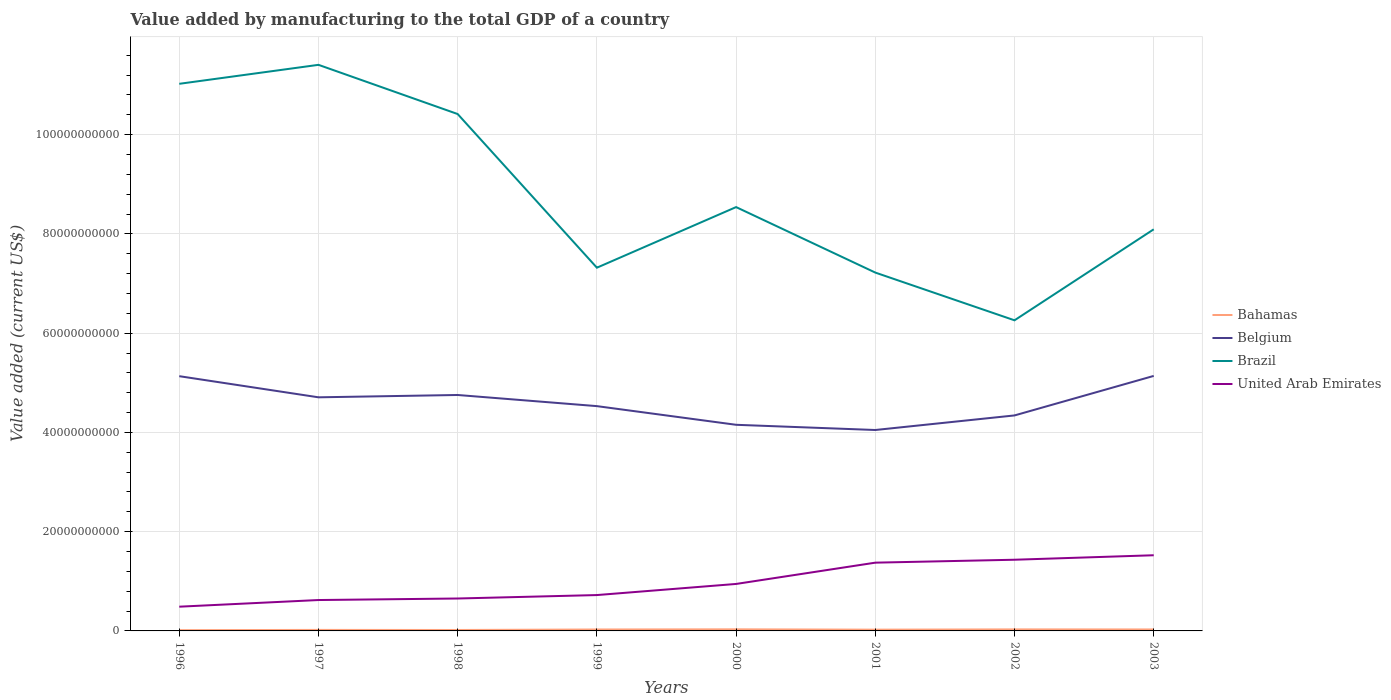Does the line corresponding to Belgium intersect with the line corresponding to United Arab Emirates?
Ensure brevity in your answer.  No. Across all years, what is the maximum value added by manufacturing to the total GDP in Brazil?
Provide a short and direct response. 6.26e+1. What is the total value added by manufacturing to the total GDP in Bahamas in the graph?
Offer a very short reply. 2.64e+07. What is the difference between the highest and the second highest value added by manufacturing to the total GDP in Belgium?
Provide a succinct answer. 1.09e+1. What is the difference between the highest and the lowest value added by manufacturing to the total GDP in United Arab Emirates?
Make the answer very short. 3. How many lines are there?
Provide a short and direct response. 4. Does the graph contain grids?
Keep it short and to the point. Yes. How are the legend labels stacked?
Offer a very short reply. Vertical. What is the title of the graph?
Your answer should be compact. Value added by manufacturing to the total GDP of a country. What is the label or title of the Y-axis?
Keep it short and to the point. Value added (current US$). What is the Value added (current US$) of Bahamas in 1996?
Your answer should be very brief. 1.54e+08. What is the Value added (current US$) in Belgium in 1996?
Ensure brevity in your answer.  5.13e+1. What is the Value added (current US$) of Brazil in 1996?
Give a very brief answer. 1.10e+11. What is the Value added (current US$) in United Arab Emirates in 1996?
Make the answer very short. 4.88e+09. What is the Value added (current US$) in Bahamas in 1997?
Provide a succinct answer. 2.05e+08. What is the Value added (current US$) of Belgium in 1997?
Make the answer very short. 4.71e+1. What is the Value added (current US$) in Brazil in 1997?
Your answer should be very brief. 1.14e+11. What is the Value added (current US$) of United Arab Emirates in 1997?
Keep it short and to the point. 6.22e+09. What is the Value added (current US$) of Bahamas in 1998?
Offer a very short reply. 1.88e+08. What is the Value added (current US$) of Belgium in 1998?
Your response must be concise. 4.75e+1. What is the Value added (current US$) of Brazil in 1998?
Keep it short and to the point. 1.04e+11. What is the Value added (current US$) in United Arab Emirates in 1998?
Keep it short and to the point. 6.53e+09. What is the Value added (current US$) of Bahamas in 1999?
Make the answer very short. 2.90e+08. What is the Value added (current US$) of Belgium in 1999?
Make the answer very short. 4.53e+1. What is the Value added (current US$) in Brazil in 1999?
Offer a very short reply. 7.32e+1. What is the Value added (current US$) in United Arab Emirates in 1999?
Provide a short and direct response. 7.23e+09. What is the Value added (current US$) in Bahamas in 2000?
Keep it short and to the point. 3.22e+08. What is the Value added (current US$) of Belgium in 2000?
Ensure brevity in your answer.  4.15e+1. What is the Value added (current US$) of Brazil in 2000?
Your answer should be very brief. 8.54e+1. What is the Value added (current US$) of United Arab Emirates in 2000?
Keep it short and to the point. 9.47e+09. What is the Value added (current US$) of Bahamas in 2001?
Provide a short and direct response. 2.54e+08. What is the Value added (current US$) in Belgium in 2001?
Ensure brevity in your answer.  4.05e+1. What is the Value added (current US$) of Brazil in 2001?
Ensure brevity in your answer.  7.22e+1. What is the Value added (current US$) in United Arab Emirates in 2001?
Provide a succinct answer. 1.38e+1. What is the Value added (current US$) of Bahamas in 2002?
Offer a terse response. 3.09e+08. What is the Value added (current US$) of Belgium in 2002?
Keep it short and to the point. 4.34e+1. What is the Value added (current US$) of Brazil in 2002?
Your answer should be very brief. 6.26e+1. What is the Value added (current US$) in United Arab Emirates in 2002?
Offer a terse response. 1.43e+1. What is the Value added (current US$) in Bahamas in 2003?
Provide a short and direct response. 2.95e+08. What is the Value added (current US$) in Belgium in 2003?
Your answer should be compact. 5.14e+1. What is the Value added (current US$) of Brazil in 2003?
Make the answer very short. 8.09e+1. What is the Value added (current US$) of United Arab Emirates in 2003?
Offer a very short reply. 1.52e+1. Across all years, what is the maximum Value added (current US$) of Bahamas?
Offer a very short reply. 3.22e+08. Across all years, what is the maximum Value added (current US$) in Belgium?
Keep it short and to the point. 5.14e+1. Across all years, what is the maximum Value added (current US$) in Brazil?
Offer a terse response. 1.14e+11. Across all years, what is the maximum Value added (current US$) of United Arab Emirates?
Your response must be concise. 1.52e+1. Across all years, what is the minimum Value added (current US$) of Bahamas?
Ensure brevity in your answer.  1.54e+08. Across all years, what is the minimum Value added (current US$) of Belgium?
Ensure brevity in your answer.  4.05e+1. Across all years, what is the minimum Value added (current US$) of Brazil?
Offer a terse response. 6.26e+1. Across all years, what is the minimum Value added (current US$) in United Arab Emirates?
Your response must be concise. 4.88e+09. What is the total Value added (current US$) of Bahamas in the graph?
Give a very brief answer. 2.02e+09. What is the total Value added (current US$) in Belgium in the graph?
Offer a terse response. 3.68e+11. What is the total Value added (current US$) of Brazil in the graph?
Provide a short and direct response. 7.03e+11. What is the total Value added (current US$) in United Arab Emirates in the graph?
Offer a very short reply. 7.77e+1. What is the difference between the Value added (current US$) of Bahamas in 1996 and that in 1997?
Your answer should be compact. -5.09e+07. What is the difference between the Value added (current US$) of Belgium in 1996 and that in 1997?
Give a very brief answer. 4.26e+09. What is the difference between the Value added (current US$) in Brazil in 1996 and that in 1997?
Provide a succinct answer. -3.82e+09. What is the difference between the Value added (current US$) in United Arab Emirates in 1996 and that in 1997?
Your response must be concise. -1.34e+09. What is the difference between the Value added (current US$) of Bahamas in 1996 and that in 1998?
Keep it short and to the point. -3.41e+07. What is the difference between the Value added (current US$) of Belgium in 1996 and that in 1998?
Give a very brief answer. 3.79e+09. What is the difference between the Value added (current US$) in Brazil in 1996 and that in 1998?
Offer a very short reply. 6.09e+09. What is the difference between the Value added (current US$) in United Arab Emirates in 1996 and that in 1998?
Give a very brief answer. -1.65e+09. What is the difference between the Value added (current US$) in Bahamas in 1996 and that in 1999?
Provide a succinct answer. -1.36e+08. What is the difference between the Value added (current US$) in Belgium in 1996 and that in 1999?
Provide a succinct answer. 6.03e+09. What is the difference between the Value added (current US$) of Brazil in 1996 and that in 1999?
Make the answer very short. 3.71e+1. What is the difference between the Value added (current US$) in United Arab Emirates in 1996 and that in 1999?
Provide a short and direct response. -2.34e+09. What is the difference between the Value added (current US$) in Bahamas in 1996 and that in 2000?
Make the answer very short. -1.68e+08. What is the difference between the Value added (current US$) in Belgium in 1996 and that in 2000?
Provide a short and direct response. 9.80e+09. What is the difference between the Value added (current US$) of Brazil in 1996 and that in 2000?
Your answer should be compact. 2.48e+1. What is the difference between the Value added (current US$) in United Arab Emirates in 1996 and that in 2000?
Your response must be concise. -4.58e+09. What is the difference between the Value added (current US$) in Bahamas in 1996 and that in 2001?
Your answer should be compact. -9.97e+07. What is the difference between the Value added (current US$) in Belgium in 1996 and that in 2001?
Offer a terse response. 1.08e+1. What is the difference between the Value added (current US$) in Brazil in 1996 and that in 2001?
Provide a short and direct response. 3.80e+1. What is the difference between the Value added (current US$) in United Arab Emirates in 1996 and that in 2001?
Your response must be concise. -8.87e+09. What is the difference between the Value added (current US$) in Bahamas in 1996 and that in 2002?
Ensure brevity in your answer.  -1.55e+08. What is the difference between the Value added (current US$) in Belgium in 1996 and that in 2002?
Give a very brief answer. 7.91e+09. What is the difference between the Value added (current US$) in Brazil in 1996 and that in 2002?
Offer a terse response. 4.77e+1. What is the difference between the Value added (current US$) in United Arab Emirates in 1996 and that in 2002?
Make the answer very short. -9.46e+09. What is the difference between the Value added (current US$) in Bahamas in 1996 and that in 2003?
Make the answer very short. -1.41e+08. What is the difference between the Value added (current US$) of Belgium in 1996 and that in 2003?
Your answer should be compact. -5.35e+07. What is the difference between the Value added (current US$) in Brazil in 1996 and that in 2003?
Ensure brevity in your answer.  2.93e+1. What is the difference between the Value added (current US$) in United Arab Emirates in 1996 and that in 2003?
Your answer should be very brief. -1.04e+1. What is the difference between the Value added (current US$) of Bahamas in 1997 and that in 1998?
Give a very brief answer. 1.68e+07. What is the difference between the Value added (current US$) in Belgium in 1997 and that in 1998?
Provide a succinct answer. -4.68e+08. What is the difference between the Value added (current US$) of Brazil in 1997 and that in 1998?
Your answer should be compact. 9.91e+09. What is the difference between the Value added (current US$) of United Arab Emirates in 1997 and that in 1998?
Keep it short and to the point. -3.07e+08. What is the difference between the Value added (current US$) in Bahamas in 1997 and that in 1999?
Offer a very short reply. -8.48e+07. What is the difference between the Value added (current US$) of Belgium in 1997 and that in 1999?
Give a very brief answer. 1.78e+09. What is the difference between the Value added (current US$) in Brazil in 1997 and that in 1999?
Your answer should be very brief. 4.09e+1. What is the difference between the Value added (current US$) in United Arab Emirates in 1997 and that in 1999?
Offer a very short reply. -1.00e+09. What is the difference between the Value added (current US$) in Bahamas in 1997 and that in 2000?
Offer a very short reply. -1.17e+08. What is the difference between the Value added (current US$) of Belgium in 1997 and that in 2000?
Your response must be concise. 5.54e+09. What is the difference between the Value added (current US$) in Brazil in 1997 and that in 2000?
Your answer should be very brief. 2.87e+1. What is the difference between the Value added (current US$) in United Arab Emirates in 1997 and that in 2000?
Offer a very short reply. -3.24e+09. What is the difference between the Value added (current US$) in Bahamas in 1997 and that in 2001?
Make the answer very short. -4.89e+07. What is the difference between the Value added (current US$) of Belgium in 1997 and that in 2001?
Give a very brief answer. 6.59e+09. What is the difference between the Value added (current US$) of Brazil in 1997 and that in 2001?
Offer a very short reply. 4.19e+1. What is the difference between the Value added (current US$) of United Arab Emirates in 1997 and that in 2001?
Your response must be concise. -7.53e+09. What is the difference between the Value added (current US$) in Bahamas in 1997 and that in 2002?
Provide a short and direct response. -1.04e+08. What is the difference between the Value added (current US$) of Belgium in 1997 and that in 2002?
Provide a short and direct response. 3.65e+09. What is the difference between the Value added (current US$) in Brazil in 1997 and that in 2002?
Keep it short and to the point. 5.15e+1. What is the difference between the Value added (current US$) of United Arab Emirates in 1997 and that in 2002?
Provide a succinct answer. -8.12e+09. What is the difference between the Value added (current US$) in Bahamas in 1997 and that in 2003?
Your response must be concise. -9.03e+07. What is the difference between the Value added (current US$) in Belgium in 1997 and that in 2003?
Your answer should be compact. -4.31e+09. What is the difference between the Value added (current US$) in Brazil in 1997 and that in 2003?
Ensure brevity in your answer.  3.31e+1. What is the difference between the Value added (current US$) of United Arab Emirates in 1997 and that in 2003?
Your answer should be very brief. -9.02e+09. What is the difference between the Value added (current US$) of Bahamas in 1998 and that in 1999?
Your answer should be compact. -1.02e+08. What is the difference between the Value added (current US$) of Belgium in 1998 and that in 1999?
Offer a terse response. 2.24e+09. What is the difference between the Value added (current US$) of Brazil in 1998 and that in 1999?
Offer a very short reply. 3.10e+1. What is the difference between the Value added (current US$) in United Arab Emirates in 1998 and that in 1999?
Provide a short and direct response. -6.95e+08. What is the difference between the Value added (current US$) in Bahamas in 1998 and that in 2000?
Make the answer very short. -1.34e+08. What is the difference between the Value added (current US$) of Belgium in 1998 and that in 2000?
Provide a succinct answer. 6.01e+09. What is the difference between the Value added (current US$) in Brazil in 1998 and that in 2000?
Offer a terse response. 1.87e+1. What is the difference between the Value added (current US$) of United Arab Emirates in 1998 and that in 2000?
Your answer should be compact. -2.93e+09. What is the difference between the Value added (current US$) in Bahamas in 1998 and that in 2001?
Give a very brief answer. -6.57e+07. What is the difference between the Value added (current US$) in Belgium in 1998 and that in 2001?
Your response must be concise. 7.05e+09. What is the difference between the Value added (current US$) of Brazil in 1998 and that in 2001?
Your response must be concise. 3.19e+1. What is the difference between the Value added (current US$) in United Arab Emirates in 1998 and that in 2001?
Make the answer very short. -7.22e+09. What is the difference between the Value added (current US$) in Bahamas in 1998 and that in 2002?
Your answer should be very brief. -1.21e+08. What is the difference between the Value added (current US$) in Belgium in 1998 and that in 2002?
Offer a terse response. 4.12e+09. What is the difference between the Value added (current US$) of Brazil in 1998 and that in 2002?
Your answer should be compact. 4.16e+1. What is the difference between the Value added (current US$) of United Arab Emirates in 1998 and that in 2002?
Provide a short and direct response. -7.81e+09. What is the difference between the Value added (current US$) in Bahamas in 1998 and that in 2003?
Offer a very short reply. -1.07e+08. What is the difference between the Value added (current US$) in Belgium in 1998 and that in 2003?
Your answer should be compact. -3.84e+09. What is the difference between the Value added (current US$) in Brazil in 1998 and that in 2003?
Offer a terse response. 2.32e+1. What is the difference between the Value added (current US$) in United Arab Emirates in 1998 and that in 2003?
Provide a succinct answer. -8.72e+09. What is the difference between the Value added (current US$) in Bahamas in 1999 and that in 2000?
Keep it short and to the point. -3.19e+07. What is the difference between the Value added (current US$) in Belgium in 1999 and that in 2000?
Your response must be concise. 3.76e+09. What is the difference between the Value added (current US$) in Brazil in 1999 and that in 2000?
Your answer should be compact. -1.22e+1. What is the difference between the Value added (current US$) in United Arab Emirates in 1999 and that in 2000?
Ensure brevity in your answer.  -2.24e+09. What is the difference between the Value added (current US$) in Bahamas in 1999 and that in 2001?
Ensure brevity in your answer.  3.59e+07. What is the difference between the Value added (current US$) in Belgium in 1999 and that in 2001?
Make the answer very short. 4.81e+09. What is the difference between the Value added (current US$) in Brazil in 1999 and that in 2001?
Keep it short and to the point. 9.84e+08. What is the difference between the Value added (current US$) in United Arab Emirates in 1999 and that in 2001?
Make the answer very short. -6.53e+09. What is the difference between the Value added (current US$) of Bahamas in 1999 and that in 2002?
Ensure brevity in your answer.  -1.96e+07. What is the difference between the Value added (current US$) of Belgium in 1999 and that in 2002?
Your answer should be very brief. 1.87e+09. What is the difference between the Value added (current US$) of Brazil in 1999 and that in 2002?
Give a very brief answer. 1.06e+1. What is the difference between the Value added (current US$) of United Arab Emirates in 1999 and that in 2002?
Provide a succinct answer. -7.12e+09. What is the difference between the Value added (current US$) of Bahamas in 1999 and that in 2003?
Offer a terse response. -5.49e+06. What is the difference between the Value added (current US$) in Belgium in 1999 and that in 2003?
Provide a succinct answer. -6.09e+09. What is the difference between the Value added (current US$) of Brazil in 1999 and that in 2003?
Provide a succinct answer. -7.74e+09. What is the difference between the Value added (current US$) in United Arab Emirates in 1999 and that in 2003?
Give a very brief answer. -8.02e+09. What is the difference between the Value added (current US$) of Bahamas in 2000 and that in 2001?
Your answer should be very brief. 6.78e+07. What is the difference between the Value added (current US$) of Belgium in 2000 and that in 2001?
Your response must be concise. 1.05e+09. What is the difference between the Value added (current US$) in Brazil in 2000 and that in 2001?
Your answer should be very brief. 1.32e+1. What is the difference between the Value added (current US$) of United Arab Emirates in 2000 and that in 2001?
Your answer should be very brief. -4.29e+09. What is the difference between the Value added (current US$) in Bahamas in 2000 and that in 2002?
Your answer should be very brief. 1.23e+07. What is the difference between the Value added (current US$) in Belgium in 2000 and that in 2002?
Provide a short and direct response. -1.89e+09. What is the difference between the Value added (current US$) of Brazil in 2000 and that in 2002?
Keep it short and to the point. 2.28e+1. What is the difference between the Value added (current US$) in United Arab Emirates in 2000 and that in 2002?
Your response must be concise. -4.88e+09. What is the difference between the Value added (current US$) in Bahamas in 2000 and that in 2003?
Give a very brief answer. 2.64e+07. What is the difference between the Value added (current US$) of Belgium in 2000 and that in 2003?
Provide a succinct answer. -9.85e+09. What is the difference between the Value added (current US$) of Brazil in 2000 and that in 2003?
Ensure brevity in your answer.  4.48e+09. What is the difference between the Value added (current US$) of United Arab Emirates in 2000 and that in 2003?
Your answer should be very brief. -5.78e+09. What is the difference between the Value added (current US$) in Bahamas in 2001 and that in 2002?
Keep it short and to the point. -5.56e+07. What is the difference between the Value added (current US$) of Belgium in 2001 and that in 2002?
Your answer should be very brief. -2.94e+09. What is the difference between the Value added (current US$) in Brazil in 2001 and that in 2002?
Offer a terse response. 9.62e+09. What is the difference between the Value added (current US$) in United Arab Emirates in 2001 and that in 2002?
Keep it short and to the point. -5.91e+08. What is the difference between the Value added (current US$) of Bahamas in 2001 and that in 2003?
Your answer should be compact. -4.14e+07. What is the difference between the Value added (current US$) of Belgium in 2001 and that in 2003?
Your answer should be compact. -1.09e+1. What is the difference between the Value added (current US$) in Brazil in 2001 and that in 2003?
Your answer should be compact. -8.72e+09. What is the difference between the Value added (current US$) of United Arab Emirates in 2001 and that in 2003?
Provide a short and direct response. -1.49e+09. What is the difference between the Value added (current US$) in Bahamas in 2002 and that in 2003?
Your response must be concise. 1.41e+07. What is the difference between the Value added (current US$) of Belgium in 2002 and that in 2003?
Provide a succinct answer. -7.96e+09. What is the difference between the Value added (current US$) of Brazil in 2002 and that in 2003?
Your response must be concise. -1.83e+1. What is the difference between the Value added (current US$) of United Arab Emirates in 2002 and that in 2003?
Make the answer very short. -9.02e+08. What is the difference between the Value added (current US$) of Bahamas in 1996 and the Value added (current US$) of Belgium in 1997?
Provide a short and direct response. -4.69e+1. What is the difference between the Value added (current US$) of Bahamas in 1996 and the Value added (current US$) of Brazil in 1997?
Provide a succinct answer. -1.14e+11. What is the difference between the Value added (current US$) in Bahamas in 1996 and the Value added (current US$) in United Arab Emirates in 1997?
Give a very brief answer. -6.07e+09. What is the difference between the Value added (current US$) in Belgium in 1996 and the Value added (current US$) in Brazil in 1997?
Offer a very short reply. -6.27e+1. What is the difference between the Value added (current US$) of Belgium in 1996 and the Value added (current US$) of United Arab Emirates in 1997?
Make the answer very short. 4.51e+1. What is the difference between the Value added (current US$) in Brazil in 1996 and the Value added (current US$) in United Arab Emirates in 1997?
Provide a succinct answer. 1.04e+11. What is the difference between the Value added (current US$) of Bahamas in 1996 and the Value added (current US$) of Belgium in 1998?
Your answer should be very brief. -4.74e+1. What is the difference between the Value added (current US$) of Bahamas in 1996 and the Value added (current US$) of Brazil in 1998?
Offer a terse response. -1.04e+11. What is the difference between the Value added (current US$) in Bahamas in 1996 and the Value added (current US$) in United Arab Emirates in 1998?
Provide a short and direct response. -6.38e+09. What is the difference between the Value added (current US$) in Belgium in 1996 and the Value added (current US$) in Brazil in 1998?
Your answer should be compact. -5.28e+1. What is the difference between the Value added (current US$) in Belgium in 1996 and the Value added (current US$) in United Arab Emirates in 1998?
Make the answer very short. 4.48e+1. What is the difference between the Value added (current US$) of Brazil in 1996 and the Value added (current US$) of United Arab Emirates in 1998?
Your response must be concise. 1.04e+11. What is the difference between the Value added (current US$) in Bahamas in 1996 and the Value added (current US$) in Belgium in 1999?
Make the answer very short. -4.51e+1. What is the difference between the Value added (current US$) of Bahamas in 1996 and the Value added (current US$) of Brazil in 1999?
Ensure brevity in your answer.  -7.30e+1. What is the difference between the Value added (current US$) of Bahamas in 1996 and the Value added (current US$) of United Arab Emirates in 1999?
Make the answer very short. -7.07e+09. What is the difference between the Value added (current US$) in Belgium in 1996 and the Value added (current US$) in Brazil in 1999?
Provide a short and direct response. -2.19e+1. What is the difference between the Value added (current US$) of Belgium in 1996 and the Value added (current US$) of United Arab Emirates in 1999?
Offer a very short reply. 4.41e+1. What is the difference between the Value added (current US$) of Brazil in 1996 and the Value added (current US$) of United Arab Emirates in 1999?
Keep it short and to the point. 1.03e+11. What is the difference between the Value added (current US$) of Bahamas in 1996 and the Value added (current US$) of Belgium in 2000?
Offer a very short reply. -4.14e+1. What is the difference between the Value added (current US$) in Bahamas in 1996 and the Value added (current US$) in Brazil in 2000?
Ensure brevity in your answer.  -8.52e+1. What is the difference between the Value added (current US$) in Bahamas in 1996 and the Value added (current US$) in United Arab Emirates in 2000?
Make the answer very short. -9.31e+09. What is the difference between the Value added (current US$) of Belgium in 1996 and the Value added (current US$) of Brazil in 2000?
Make the answer very short. -3.41e+1. What is the difference between the Value added (current US$) of Belgium in 1996 and the Value added (current US$) of United Arab Emirates in 2000?
Provide a short and direct response. 4.19e+1. What is the difference between the Value added (current US$) in Brazil in 1996 and the Value added (current US$) in United Arab Emirates in 2000?
Provide a succinct answer. 1.01e+11. What is the difference between the Value added (current US$) of Bahamas in 1996 and the Value added (current US$) of Belgium in 2001?
Make the answer very short. -4.03e+1. What is the difference between the Value added (current US$) in Bahamas in 1996 and the Value added (current US$) in Brazil in 2001?
Keep it short and to the point. -7.21e+1. What is the difference between the Value added (current US$) in Bahamas in 1996 and the Value added (current US$) in United Arab Emirates in 2001?
Provide a succinct answer. -1.36e+1. What is the difference between the Value added (current US$) of Belgium in 1996 and the Value added (current US$) of Brazil in 2001?
Provide a short and direct response. -2.09e+1. What is the difference between the Value added (current US$) of Belgium in 1996 and the Value added (current US$) of United Arab Emirates in 2001?
Your answer should be compact. 3.76e+1. What is the difference between the Value added (current US$) of Brazil in 1996 and the Value added (current US$) of United Arab Emirates in 2001?
Your answer should be very brief. 9.65e+1. What is the difference between the Value added (current US$) of Bahamas in 1996 and the Value added (current US$) of Belgium in 2002?
Ensure brevity in your answer.  -4.33e+1. What is the difference between the Value added (current US$) of Bahamas in 1996 and the Value added (current US$) of Brazil in 2002?
Keep it short and to the point. -6.24e+1. What is the difference between the Value added (current US$) in Bahamas in 1996 and the Value added (current US$) in United Arab Emirates in 2002?
Give a very brief answer. -1.42e+1. What is the difference between the Value added (current US$) in Belgium in 1996 and the Value added (current US$) in Brazil in 2002?
Provide a succinct answer. -1.13e+1. What is the difference between the Value added (current US$) of Belgium in 1996 and the Value added (current US$) of United Arab Emirates in 2002?
Provide a short and direct response. 3.70e+1. What is the difference between the Value added (current US$) of Brazil in 1996 and the Value added (current US$) of United Arab Emirates in 2002?
Keep it short and to the point. 9.59e+1. What is the difference between the Value added (current US$) of Bahamas in 1996 and the Value added (current US$) of Belgium in 2003?
Provide a short and direct response. -5.12e+1. What is the difference between the Value added (current US$) in Bahamas in 1996 and the Value added (current US$) in Brazil in 2003?
Your answer should be compact. -8.08e+1. What is the difference between the Value added (current US$) of Bahamas in 1996 and the Value added (current US$) of United Arab Emirates in 2003?
Make the answer very short. -1.51e+1. What is the difference between the Value added (current US$) of Belgium in 1996 and the Value added (current US$) of Brazil in 2003?
Offer a terse response. -2.96e+1. What is the difference between the Value added (current US$) of Belgium in 1996 and the Value added (current US$) of United Arab Emirates in 2003?
Your response must be concise. 3.61e+1. What is the difference between the Value added (current US$) in Brazil in 1996 and the Value added (current US$) in United Arab Emirates in 2003?
Offer a very short reply. 9.50e+1. What is the difference between the Value added (current US$) in Bahamas in 1997 and the Value added (current US$) in Belgium in 1998?
Your response must be concise. -4.73e+1. What is the difference between the Value added (current US$) of Bahamas in 1997 and the Value added (current US$) of Brazil in 1998?
Ensure brevity in your answer.  -1.04e+11. What is the difference between the Value added (current US$) in Bahamas in 1997 and the Value added (current US$) in United Arab Emirates in 1998?
Make the answer very short. -6.33e+09. What is the difference between the Value added (current US$) in Belgium in 1997 and the Value added (current US$) in Brazil in 1998?
Provide a succinct answer. -5.71e+1. What is the difference between the Value added (current US$) in Belgium in 1997 and the Value added (current US$) in United Arab Emirates in 1998?
Make the answer very short. 4.05e+1. What is the difference between the Value added (current US$) in Brazil in 1997 and the Value added (current US$) in United Arab Emirates in 1998?
Your answer should be very brief. 1.08e+11. What is the difference between the Value added (current US$) of Bahamas in 1997 and the Value added (current US$) of Belgium in 1999?
Offer a very short reply. -4.51e+1. What is the difference between the Value added (current US$) of Bahamas in 1997 and the Value added (current US$) of Brazil in 1999?
Your response must be concise. -7.30e+1. What is the difference between the Value added (current US$) in Bahamas in 1997 and the Value added (current US$) in United Arab Emirates in 1999?
Offer a terse response. -7.02e+09. What is the difference between the Value added (current US$) of Belgium in 1997 and the Value added (current US$) of Brazil in 1999?
Make the answer very short. -2.61e+1. What is the difference between the Value added (current US$) of Belgium in 1997 and the Value added (current US$) of United Arab Emirates in 1999?
Your response must be concise. 3.98e+1. What is the difference between the Value added (current US$) of Brazil in 1997 and the Value added (current US$) of United Arab Emirates in 1999?
Ensure brevity in your answer.  1.07e+11. What is the difference between the Value added (current US$) in Bahamas in 1997 and the Value added (current US$) in Belgium in 2000?
Provide a succinct answer. -4.13e+1. What is the difference between the Value added (current US$) in Bahamas in 1997 and the Value added (current US$) in Brazil in 2000?
Provide a short and direct response. -8.52e+1. What is the difference between the Value added (current US$) in Bahamas in 1997 and the Value added (current US$) in United Arab Emirates in 2000?
Ensure brevity in your answer.  -9.26e+09. What is the difference between the Value added (current US$) of Belgium in 1997 and the Value added (current US$) of Brazil in 2000?
Your answer should be compact. -3.83e+1. What is the difference between the Value added (current US$) of Belgium in 1997 and the Value added (current US$) of United Arab Emirates in 2000?
Make the answer very short. 3.76e+1. What is the difference between the Value added (current US$) of Brazil in 1997 and the Value added (current US$) of United Arab Emirates in 2000?
Your response must be concise. 1.05e+11. What is the difference between the Value added (current US$) in Bahamas in 1997 and the Value added (current US$) in Belgium in 2001?
Provide a short and direct response. -4.03e+1. What is the difference between the Value added (current US$) in Bahamas in 1997 and the Value added (current US$) in Brazil in 2001?
Ensure brevity in your answer.  -7.20e+1. What is the difference between the Value added (current US$) of Bahamas in 1997 and the Value added (current US$) of United Arab Emirates in 2001?
Offer a terse response. -1.35e+1. What is the difference between the Value added (current US$) of Belgium in 1997 and the Value added (current US$) of Brazil in 2001?
Your response must be concise. -2.51e+1. What is the difference between the Value added (current US$) of Belgium in 1997 and the Value added (current US$) of United Arab Emirates in 2001?
Your response must be concise. 3.33e+1. What is the difference between the Value added (current US$) of Brazil in 1997 and the Value added (current US$) of United Arab Emirates in 2001?
Make the answer very short. 1.00e+11. What is the difference between the Value added (current US$) of Bahamas in 1997 and the Value added (current US$) of Belgium in 2002?
Offer a terse response. -4.32e+1. What is the difference between the Value added (current US$) of Bahamas in 1997 and the Value added (current US$) of Brazil in 2002?
Offer a terse response. -6.24e+1. What is the difference between the Value added (current US$) in Bahamas in 1997 and the Value added (current US$) in United Arab Emirates in 2002?
Offer a very short reply. -1.41e+1. What is the difference between the Value added (current US$) in Belgium in 1997 and the Value added (current US$) in Brazil in 2002?
Your response must be concise. -1.55e+1. What is the difference between the Value added (current US$) of Belgium in 1997 and the Value added (current US$) of United Arab Emirates in 2002?
Ensure brevity in your answer.  3.27e+1. What is the difference between the Value added (current US$) of Brazil in 1997 and the Value added (current US$) of United Arab Emirates in 2002?
Provide a short and direct response. 9.97e+1. What is the difference between the Value added (current US$) in Bahamas in 1997 and the Value added (current US$) in Belgium in 2003?
Ensure brevity in your answer.  -5.12e+1. What is the difference between the Value added (current US$) in Bahamas in 1997 and the Value added (current US$) in Brazil in 2003?
Your answer should be compact. -8.07e+1. What is the difference between the Value added (current US$) in Bahamas in 1997 and the Value added (current US$) in United Arab Emirates in 2003?
Provide a short and direct response. -1.50e+1. What is the difference between the Value added (current US$) in Belgium in 1997 and the Value added (current US$) in Brazil in 2003?
Your response must be concise. -3.39e+1. What is the difference between the Value added (current US$) of Belgium in 1997 and the Value added (current US$) of United Arab Emirates in 2003?
Make the answer very short. 3.18e+1. What is the difference between the Value added (current US$) of Brazil in 1997 and the Value added (current US$) of United Arab Emirates in 2003?
Make the answer very short. 9.88e+1. What is the difference between the Value added (current US$) of Bahamas in 1998 and the Value added (current US$) of Belgium in 1999?
Your answer should be very brief. -4.51e+1. What is the difference between the Value added (current US$) in Bahamas in 1998 and the Value added (current US$) in Brazil in 1999?
Provide a succinct answer. -7.30e+1. What is the difference between the Value added (current US$) of Bahamas in 1998 and the Value added (current US$) of United Arab Emirates in 1999?
Give a very brief answer. -7.04e+09. What is the difference between the Value added (current US$) in Belgium in 1998 and the Value added (current US$) in Brazil in 1999?
Provide a short and direct response. -2.56e+1. What is the difference between the Value added (current US$) in Belgium in 1998 and the Value added (current US$) in United Arab Emirates in 1999?
Provide a succinct answer. 4.03e+1. What is the difference between the Value added (current US$) in Brazil in 1998 and the Value added (current US$) in United Arab Emirates in 1999?
Your response must be concise. 9.69e+1. What is the difference between the Value added (current US$) of Bahamas in 1998 and the Value added (current US$) of Belgium in 2000?
Give a very brief answer. -4.13e+1. What is the difference between the Value added (current US$) of Bahamas in 1998 and the Value added (current US$) of Brazil in 2000?
Keep it short and to the point. -8.52e+1. What is the difference between the Value added (current US$) of Bahamas in 1998 and the Value added (current US$) of United Arab Emirates in 2000?
Provide a succinct answer. -9.28e+09. What is the difference between the Value added (current US$) in Belgium in 1998 and the Value added (current US$) in Brazil in 2000?
Keep it short and to the point. -3.79e+1. What is the difference between the Value added (current US$) in Belgium in 1998 and the Value added (current US$) in United Arab Emirates in 2000?
Offer a terse response. 3.81e+1. What is the difference between the Value added (current US$) in Brazil in 1998 and the Value added (current US$) in United Arab Emirates in 2000?
Your response must be concise. 9.47e+1. What is the difference between the Value added (current US$) in Bahamas in 1998 and the Value added (current US$) in Belgium in 2001?
Ensure brevity in your answer.  -4.03e+1. What is the difference between the Value added (current US$) of Bahamas in 1998 and the Value added (current US$) of Brazil in 2001?
Your answer should be very brief. -7.20e+1. What is the difference between the Value added (current US$) in Bahamas in 1998 and the Value added (current US$) in United Arab Emirates in 2001?
Provide a short and direct response. -1.36e+1. What is the difference between the Value added (current US$) of Belgium in 1998 and the Value added (current US$) of Brazil in 2001?
Offer a very short reply. -2.47e+1. What is the difference between the Value added (current US$) in Belgium in 1998 and the Value added (current US$) in United Arab Emirates in 2001?
Ensure brevity in your answer.  3.38e+1. What is the difference between the Value added (current US$) of Brazil in 1998 and the Value added (current US$) of United Arab Emirates in 2001?
Your response must be concise. 9.04e+1. What is the difference between the Value added (current US$) of Bahamas in 1998 and the Value added (current US$) of Belgium in 2002?
Your answer should be compact. -4.32e+1. What is the difference between the Value added (current US$) in Bahamas in 1998 and the Value added (current US$) in Brazil in 2002?
Your response must be concise. -6.24e+1. What is the difference between the Value added (current US$) in Bahamas in 1998 and the Value added (current US$) in United Arab Emirates in 2002?
Provide a succinct answer. -1.42e+1. What is the difference between the Value added (current US$) of Belgium in 1998 and the Value added (current US$) of Brazil in 2002?
Ensure brevity in your answer.  -1.50e+1. What is the difference between the Value added (current US$) of Belgium in 1998 and the Value added (current US$) of United Arab Emirates in 2002?
Your answer should be very brief. 3.32e+1. What is the difference between the Value added (current US$) in Brazil in 1998 and the Value added (current US$) in United Arab Emirates in 2002?
Make the answer very short. 8.98e+1. What is the difference between the Value added (current US$) of Bahamas in 1998 and the Value added (current US$) of Belgium in 2003?
Give a very brief answer. -5.12e+1. What is the difference between the Value added (current US$) of Bahamas in 1998 and the Value added (current US$) of Brazil in 2003?
Offer a terse response. -8.07e+1. What is the difference between the Value added (current US$) of Bahamas in 1998 and the Value added (current US$) of United Arab Emirates in 2003?
Ensure brevity in your answer.  -1.51e+1. What is the difference between the Value added (current US$) of Belgium in 1998 and the Value added (current US$) of Brazil in 2003?
Keep it short and to the point. -3.34e+1. What is the difference between the Value added (current US$) in Belgium in 1998 and the Value added (current US$) in United Arab Emirates in 2003?
Your answer should be very brief. 3.23e+1. What is the difference between the Value added (current US$) in Brazil in 1998 and the Value added (current US$) in United Arab Emirates in 2003?
Provide a short and direct response. 8.89e+1. What is the difference between the Value added (current US$) of Bahamas in 1999 and the Value added (current US$) of Belgium in 2000?
Provide a succinct answer. -4.12e+1. What is the difference between the Value added (current US$) of Bahamas in 1999 and the Value added (current US$) of Brazil in 2000?
Your answer should be compact. -8.51e+1. What is the difference between the Value added (current US$) of Bahamas in 1999 and the Value added (current US$) of United Arab Emirates in 2000?
Keep it short and to the point. -9.18e+09. What is the difference between the Value added (current US$) of Belgium in 1999 and the Value added (current US$) of Brazil in 2000?
Offer a terse response. -4.01e+1. What is the difference between the Value added (current US$) in Belgium in 1999 and the Value added (current US$) in United Arab Emirates in 2000?
Give a very brief answer. 3.58e+1. What is the difference between the Value added (current US$) in Brazil in 1999 and the Value added (current US$) in United Arab Emirates in 2000?
Your response must be concise. 6.37e+1. What is the difference between the Value added (current US$) in Bahamas in 1999 and the Value added (current US$) in Belgium in 2001?
Ensure brevity in your answer.  -4.02e+1. What is the difference between the Value added (current US$) in Bahamas in 1999 and the Value added (current US$) in Brazil in 2001?
Offer a very short reply. -7.19e+1. What is the difference between the Value added (current US$) of Bahamas in 1999 and the Value added (current US$) of United Arab Emirates in 2001?
Your answer should be very brief. -1.35e+1. What is the difference between the Value added (current US$) in Belgium in 1999 and the Value added (current US$) in Brazil in 2001?
Your response must be concise. -2.69e+1. What is the difference between the Value added (current US$) of Belgium in 1999 and the Value added (current US$) of United Arab Emirates in 2001?
Make the answer very short. 3.15e+1. What is the difference between the Value added (current US$) of Brazil in 1999 and the Value added (current US$) of United Arab Emirates in 2001?
Provide a short and direct response. 5.94e+1. What is the difference between the Value added (current US$) of Bahamas in 1999 and the Value added (current US$) of Belgium in 2002?
Your answer should be compact. -4.31e+1. What is the difference between the Value added (current US$) in Bahamas in 1999 and the Value added (current US$) in Brazil in 2002?
Provide a short and direct response. -6.23e+1. What is the difference between the Value added (current US$) in Bahamas in 1999 and the Value added (current US$) in United Arab Emirates in 2002?
Offer a terse response. -1.41e+1. What is the difference between the Value added (current US$) in Belgium in 1999 and the Value added (current US$) in Brazil in 2002?
Make the answer very short. -1.73e+1. What is the difference between the Value added (current US$) in Belgium in 1999 and the Value added (current US$) in United Arab Emirates in 2002?
Provide a short and direct response. 3.10e+1. What is the difference between the Value added (current US$) in Brazil in 1999 and the Value added (current US$) in United Arab Emirates in 2002?
Your response must be concise. 5.88e+1. What is the difference between the Value added (current US$) in Bahamas in 1999 and the Value added (current US$) in Belgium in 2003?
Your answer should be very brief. -5.11e+1. What is the difference between the Value added (current US$) of Bahamas in 1999 and the Value added (current US$) of Brazil in 2003?
Offer a terse response. -8.06e+1. What is the difference between the Value added (current US$) of Bahamas in 1999 and the Value added (current US$) of United Arab Emirates in 2003?
Ensure brevity in your answer.  -1.50e+1. What is the difference between the Value added (current US$) of Belgium in 1999 and the Value added (current US$) of Brazil in 2003?
Offer a terse response. -3.56e+1. What is the difference between the Value added (current US$) of Belgium in 1999 and the Value added (current US$) of United Arab Emirates in 2003?
Your answer should be compact. 3.00e+1. What is the difference between the Value added (current US$) of Brazil in 1999 and the Value added (current US$) of United Arab Emirates in 2003?
Offer a terse response. 5.79e+1. What is the difference between the Value added (current US$) in Bahamas in 2000 and the Value added (current US$) in Belgium in 2001?
Your answer should be compact. -4.02e+1. What is the difference between the Value added (current US$) in Bahamas in 2000 and the Value added (current US$) in Brazil in 2001?
Your answer should be very brief. -7.19e+1. What is the difference between the Value added (current US$) in Bahamas in 2000 and the Value added (current US$) in United Arab Emirates in 2001?
Ensure brevity in your answer.  -1.34e+1. What is the difference between the Value added (current US$) of Belgium in 2000 and the Value added (current US$) of Brazil in 2001?
Offer a very short reply. -3.07e+1. What is the difference between the Value added (current US$) in Belgium in 2000 and the Value added (current US$) in United Arab Emirates in 2001?
Keep it short and to the point. 2.78e+1. What is the difference between the Value added (current US$) in Brazil in 2000 and the Value added (current US$) in United Arab Emirates in 2001?
Ensure brevity in your answer.  7.16e+1. What is the difference between the Value added (current US$) in Bahamas in 2000 and the Value added (current US$) in Belgium in 2002?
Offer a very short reply. -4.31e+1. What is the difference between the Value added (current US$) of Bahamas in 2000 and the Value added (current US$) of Brazil in 2002?
Your answer should be very brief. -6.23e+1. What is the difference between the Value added (current US$) of Bahamas in 2000 and the Value added (current US$) of United Arab Emirates in 2002?
Your answer should be compact. -1.40e+1. What is the difference between the Value added (current US$) in Belgium in 2000 and the Value added (current US$) in Brazil in 2002?
Provide a succinct answer. -2.11e+1. What is the difference between the Value added (current US$) of Belgium in 2000 and the Value added (current US$) of United Arab Emirates in 2002?
Your answer should be compact. 2.72e+1. What is the difference between the Value added (current US$) of Brazil in 2000 and the Value added (current US$) of United Arab Emirates in 2002?
Your response must be concise. 7.11e+1. What is the difference between the Value added (current US$) of Bahamas in 2000 and the Value added (current US$) of Belgium in 2003?
Provide a succinct answer. -5.11e+1. What is the difference between the Value added (current US$) of Bahamas in 2000 and the Value added (current US$) of Brazil in 2003?
Your answer should be compact. -8.06e+1. What is the difference between the Value added (current US$) of Bahamas in 2000 and the Value added (current US$) of United Arab Emirates in 2003?
Ensure brevity in your answer.  -1.49e+1. What is the difference between the Value added (current US$) in Belgium in 2000 and the Value added (current US$) in Brazil in 2003?
Ensure brevity in your answer.  -3.94e+1. What is the difference between the Value added (current US$) of Belgium in 2000 and the Value added (current US$) of United Arab Emirates in 2003?
Give a very brief answer. 2.63e+1. What is the difference between the Value added (current US$) in Brazil in 2000 and the Value added (current US$) in United Arab Emirates in 2003?
Ensure brevity in your answer.  7.02e+1. What is the difference between the Value added (current US$) in Bahamas in 2001 and the Value added (current US$) in Belgium in 2002?
Your answer should be very brief. -4.32e+1. What is the difference between the Value added (current US$) of Bahamas in 2001 and the Value added (current US$) of Brazil in 2002?
Ensure brevity in your answer.  -6.23e+1. What is the difference between the Value added (current US$) of Bahamas in 2001 and the Value added (current US$) of United Arab Emirates in 2002?
Give a very brief answer. -1.41e+1. What is the difference between the Value added (current US$) in Belgium in 2001 and the Value added (current US$) in Brazil in 2002?
Ensure brevity in your answer.  -2.21e+1. What is the difference between the Value added (current US$) of Belgium in 2001 and the Value added (current US$) of United Arab Emirates in 2002?
Provide a succinct answer. 2.61e+1. What is the difference between the Value added (current US$) of Brazil in 2001 and the Value added (current US$) of United Arab Emirates in 2002?
Give a very brief answer. 5.79e+1. What is the difference between the Value added (current US$) in Bahamas in 2001 and the Value added (current US$) in Belgium in 2003?
Provide a succinct answer. -5.11e+1. What is the difference between the Value added (current US$) of Bahamas in 2001 and the Value added (current US$) of Brazil in 2003?
Your answer should be very brief. -8.07e+1. What is the difference between the Value added (current US$) of Bahamas in 2001 and the Value added (current US$) of United Arab Emirates in 2003?
Make the answer very short. -1.50e+1. What is the difference between the Value added (current US$) in Belgium in 2001 and the Value added (current US$) in Brazil in 2003?
Ensure brevity in your answer.  -4.04e+1. What is the difference between the Value added (current US$) in Belgium in 2001 and the Value added (current US$) in United Arab Emirates in 2003?
Offer a very short reply. 2.52e+1. What is the difference between the Value added (current US$) of Brazil in 2001 and the Value added (current US$) of United Arab Emirates in 2003?
Provide a short and direct response. 5.70e+1. What is the difference between the Value added (current US$) of Bahamas in 2002 and the Value added (current US$) of Belgium in 2003?
Your answer should be very brief. -5.11e+1. What is the difference between the Value added (current US$) in Bahamas in 2002 and the Value added (current US$) in Brazil in 2003?
Keep it short and to the point. -8.06e+1. What is the difference between the Value added (current US$) in Bahamas in 2002 and the Value added (current US$) in United Arab Emirates in 2003?
Your answer should be very brief. -1.49e+1. What is the difference between the Value added (current US$) in Belgium in 2002 and the Value added (current US$) in Brazil in 2003?
Make the answer very short. -3.75e+1. What is the difference between the Value added (current US$) of Belgium in 2002 and the Value added (current US$) of United Arab Emirates in 2003?
Keep it short and to the point. 2.82e+1. What is the difference between the Value added (current US$) in Brazil in 2002 and the Value added (current US$) in United Arab Emirates in 2003?
Offer a very short reply. 4.73e+1. What is the average Value added (current US$) in Bahamas per year?
Your response must be concise. 2.52e+08. What is the average Value added (current US$) of Belgium per year?
Provide a short and direct response. 4.60e+1. What is the average Value added (current US$) of Brazil per year?
Offer a very short reply. 8.78e+1. What is the average Value added (current US$) in United Arab Emirates per year?
Give a very brief answer. 9.71e+09. In the year 1996, what is the difference between the Value added (current US$) in Bahamas and Value added (current US$) in Belgium?
Your response must be concise. -5.12e+1. In the year 1996, what is the difference between the Value added (current US$) of Bahamas and Value added (current US$) of Brazil?
Your response must be concise. -1.10e+11. In the year 1996, what is the difference between the Value added (current US$) in Bahamas and Value added (current US$) in United Arab Emirates?
Offer a very short reply. -4.73e+09. In the year 1996, what is the difference between the Value added (current US$) of Belgium and Value added (current US$) of Brazil?
Offer a terse response. -5.89e+1. In the year 1996, what is the difference between the Value added (current US$) in Belgium and Value added (current US$) in United Arab Emirates?
Offer a terse response. 4.64e+1. In the year 1996, what is the difference between the Value added (current US$) in Brazil and Value added (current US$) in United Arab Emirates?
Ensure brevity in your answer.  1.05e+11. In the year 1997, what is the difference between the Value added (current US$) of Bahamas and Value added (current US$) of Belgium?
Ensure brevity in your answer.  -4.69e+1. In the year 1997, what is the difference between the Value added (current US$) of Bahamas and Value added (current US$) of Brazil?
Provide a succinct answer. -1.14e+11. In the year 1997, what is the difference between the Value added (current US$) in Bahamas and Value added (current US$) in United Arab Emirates?
Your answer should be compact. -6.02e+09. In the year 1997, what is the difference between the Value added (current US$) of Belgium and Value added (current US$) of Brazil?
Ensure brevity in your answer.  -6.70e+1. In the year 1997, what is the difference between the Value added (current US$) in Belgium and Value added (current US$) in United Arab Emirates?
Provide a succinct answer. 4.08e+1. In the year 1997, what is the difference between the Value added (current US$) of Brazil and Value added (current US$) of United Arab Emirates?
Your response must be concise. 1.08e+11. In the year 1998, what is the difference between the Value added (current US$) in Bahamas and Value added (current US$) in Belgium?
Give a very brief answer. -4.74e+1. In the year 1998, what is the difference between the Value added (current US$) of Bahamas and Value added (current US$) of Brazil?
Your response must be concise. -1.04e+11. In the year 1998, what is the difference between the Value added (current US$) in Bahamas and Value added (current US$) in United Arab Emirates?
Offer a very short reply. -6.34e+09. In the year 1998, what is the difference between the Value added (current US$) in Belgium and Value added (current US$) in Brazil?
Your answer should be very brief. -5.66e+1. In the year 1998, what is the difference between the Value added (current US$) in Belgium and Value added (current US$) in United Arab Emirates?
Keep it short and to the point. 4.10e+1. In the year 1998, what is the difference between the Value added (current US$) of Brazil and Value added (current US$) of United Arab Emirates?
Provide a succinct answer. 9.76e+1. In the year 1999, what is the difference between the Value added (current US$) of Bahamas and Value added (current US$) of Belgium?
Provide a short and direct response. -4.50e+1. In the year 1999, what is the difference between the Value added (current US$) in Bahamas and Value added (current US$) in Brazil?
Provide a succinct answer. -7.29e+1. In the year 1999, what is the difference between the Value added (current US$) in Bahamas and Value added (current US$) in United Arab Emirates?
Offer a terse response. -6.94e+09. In the year 1999, what is the difference between the Value added (current US$) of Belgium and Value added (current US$) of Brazil?
Offer a very short reply. -2.79e+1. In the year 1999, what is the difference between the Value added (current US$) in Belgium and Value added (current US$) in United Arab Emirates?
Keep it short and to the point. 3.81e+1. In the year 1999, what is the difference between the Value added (current US$) of Brazil and Value added (current US$) of United Arab Emirates?
Your answer should be compact. 6.60e+1. In the year 2000, what is the difference between the Value added (current US$) in Bahamas and Value added (current US$) in Belgium?
Ensure brevity in your answer.  -4.12e+1. In the year 2000, what is the difference between the Value added (current US$) of Bahamas and Value added (current US$) of Brazil?
Give a very brief answer. -8.51e+1. In the year 2000, what is the difference between the Value added (current US$) in Bahamas and Value added (current US$) in United Arab Emirates?
Your response must be concise. -9.14e+09. In the year 2000, what is the difference between the Value added (current US$) of Belgium and Value added (current US$) of Brazil?
Your answer should be very brief. -4.39e+1. In the year 2000, what is the difference between the Value added (current US$) of Belgium and Value added (current US$) of United Arab Emirates?
Offer a terse response. 3.21e+1. In the year 2000, what is the difference between the Value added (current US$) of Brazil and Value added (current US$) of United Arab Emirates?
Offer a very short reply. 7.59e+1. In the year 2001, what is the difference between the Value added (current US$) in Bahamas and Value added (current US$) in Belgium?
Ensure brevity in your answer.  -4.02e+1. In the year 2001, what is the difference between the Value added (current US$) in Bahamas and Value added (current US$) in Brazil?
Your answer should be very brief. -7.20e+1. In the year 2001, what is the difference between the Value added (current US$) in Bahamas and Value added (current US$) in United Arab Emirates?
Offer a terse response. -1.35e+1. In the year 2001, what is the difference between the Value added (current US$) of Belgium and Value added (current US$) of Brazil?
Ensure brevity in your answer.  -3.17e+1. In the year 2001, what is the difference between the Value added (current US$) of Belgium and Value added (current US$) of United Arab Emirates?
Ensure brevity in your answer.  2.67e+1. In the year 2001, what is the difference between the Value added (current US$) in Brazil and Value added (current US$) in United Arab Emirates?
Your answer should be very brief. 5.85e+1. In the year 2002, what is the difference between the Value added (current US$) of Bahamas and Value added (current US$) of Belgium?
Ensure brevity in your answer.  -4.31e+1. In the year 2002, what is the difference between the Value added (current US$) of Bahamas and Value added (current US$) of Brazil?
Offer a terse response. -6.23e+1. In the year 2002, what is the difference between the Value added (current US$) in Bahamas and Value added (current US$) in United Arab Emirates?
Give a very brief answer. -1.40e+1. In the year 2002, what is the difference between the Value added (current US$) in Belgium and Value added (current US$) in Brazil?
Offer a very short reply. -1.92e+1. In the year 2002, what is the difference between the Value added (current US$) in Belgium and Value added (current US$) in United Arab Emirates?
Your answer should be compact. 2.91e+1. In the year 2002, what is the difference between the Value added (current US$) in Brazil and Value added (current US$) in United Arab Emirates?
Keep it short and to the point. 4.82e+1. In the year 2003, what is the difference between the Value added (current US$) in Bahamas and Value added (current US$) in Belgium?
Your response must be concise. -5.11e+1. In the year 2003, what is the difference between the Value added (current US$) in Bahamas and Value added (current US$) in Brazil?
Provide a short and direct response. -8.06e+1. In the year 2003, what is the difference between the Value added (current US$) of Bahamas and Value added (current US$) of United Arab Emirates?
Give a very brief answer. -1.50e+1. In the year 2003, what is the difference between the Value added (current US$) of Belgium and Value added (current US$) of Brazil?
Make the answer very short. -2.95e+1. In the year 2003, what is the difference between the Value added (current US$) in Belgium and Value added (current US$) in United Arab Emirates?
Provide a succinct answer. 3.61e+1. In the year 2003, what is the difference between the Value added (current US$) of Brazil and Value added (current US$) of United Arab Emirates?
Provide a succinct answer. 6.57e+1. What is the ratio of the Value added (current US$) of Bahamas in 1996 to that in 1997?
Give a very brief answer. 0.75. What is the ratio of the Value added (current US$) of Belgium in 1996 to that in 1997?
Your response must be concise. 1.09. What is the ratio of the Value added (current US$) of Brazil in 1996 to that in 1997?
Your response must be concise. 0.97. What is the ratio of the Value added (current US$) of United Arab Emirates in 1996 to that in 1997?
Your answer should be very brief. 0.78. What is the ratio of the Value added (current US$) in Bahamas in 1996 to that in 1998?
Provide a succinct answer. 0.82. What is the ratio of the Value added (current US$) of Belgium in 1996 to that in 1998?
Keep it short and to the point. 1.08. What is the ratio of the Value added (current US$) of Brazil in 1996 to that in 1998?
Provide a short and direct response. 1.06. What is the ratio of the Value added (current US$) in United Arab Emirates in 1996 to that in 1998?
Keep it short and to the point. 0.75. What is the ratio of the Value added (current US$) in Bahamas in 1996 to that in 1999?
Your answer should be very brief. 0.53. What is the ratio of the Value added (current US$) of Belgium in 1996 to that in 1999?
Give a very brief answer. 1.13. What is the ratio of the Value added (current US$) of Brazil in 1996 to that in 1999?
Provide a succinct answer. 1.51. What is the ratio of the Value added (current US$) in United Arab Emirates in 1996 to that in 1999?
Ensure brevity in your answer.  0.68. What is the ratio of the Value added (current US$) in Bahamas in 1996 to that in 2000?
Offer a terse response. 0.48. What is the ratio of the Value added (current US$) of Belgium in 1996 to that in 2000?
Your answer should be compact. 1.24. What is the ratio of the Value added (current US$) of Brazil in 1996 to that in 2000?
Provide a succinct answer. 1.29. What is the ratio of the Value added (current US$) of United Arab Emirates in 1996 to that in 2000?
Your response must be concise. 0.52. What is the ratio of the Value added (current US$) in Bahamas in 1996 to that in 2001?
Your answer should be very brief. 0.61. What is the ratio of the Value added (current US$) of Belgium in 1996 to that in 2001?
Provide a short and direct response. 1.27. What is the ratio of the Value added (current US$) of Brazil in 1996 to that in 2001?
Provide a short and direct response. 1.53. What is the ratio of the Value added (current US$) in United Arab Emirates in 1996 to that in 2001?
Offer a very short reply. 0.35. What is the ratio of the Value added (current US$) in Bahamas in 1996 to that in 2002?
Your response must be concise. 0.5. What is the ratio of the Value added (current US$) of Belgium in 1996 to that in 2002?
Offer a terse response. 1.18. What is the ratio of the Value added (current US$) in Brazil in 1996 to that in 2002?
Your answer should be very brief. 1.76. What is the ratio of the Value added (current US$) in United Arab Emirates in 1996 to that in 2002?
Provide a short and direct response. 0.34. What is the ratio of the Value added (current US$) of Bahamas in 1996 to that in 2003?
Your answer should be very brief. 0.52. What is the ratio of the Value added (current US$) in Brazil in 1996 to that in 2003?
Provide a succinct answer. 1.36. What is the ratio of the Value added (current US$) of United Arab Emirates in 1996 to that in 2003?
Give a very brief answer. 0.32. What is the ratio of the Value added (current US$) of Bahamas in 1997 to that in 1998?
Provide a succinct answer. 1.09. What is the ratio of the Value added (current US$) of Belgium in 1997 to that in 1998?
Your answer should be compact. 0.99. What is the ratio of the Value added (current US$) of Brazil in 1997 to that in 1998?
Make the answer very short. 1.1. What is the ratio of the Value added (current US$) in United Arab Emirates in 1997 to that in 1998?
Provide a short and direct response. 0.95. What is the ratio of the Value added (current US$) of Bahamas in 1997 to that in 1999?
Keep it short and to the point. 0.71. What is the ratio of the Value added (current US$) in Belgium in 1997 to that in 1999?
Offer a terse response. 1.04. What is the ratio of the Value added (current US$) of Brazil in 1997 to that in 1999?
Offer a very short reply. 1.56. What is the ratio of the Value added (current US$) of United Arab Emirates in 1997 to that in 1999?
Keep it short and to the point. 0.86. What is the ratio of the Value added (current US$) in Bahamas in 1997 to that in 2000?
Your answer should be compact. 0.64. What is the ratio of the Value added (current US$) in Belgium in 1997 to that in 2000?
Your answer should be compact. 1.13. What is the ratio of the Value added (current US$) of Brazil in 1997 to that in 2000?
Provide a succinct answer. 1.34. What is the ratio of the Value added (current US$) of United Arab Emirates in 1997 to that in 2000?
Offer a terse response. 0.66. What is the ratio of the Value added (current US$) in Bahamas in 1997 to that in 2001?
Offer a terse response. 0.81. What is the ratio of the Value added (current US$) in Belgium in 1997 to that in 2001?
Your answer should be compact. 1.16. What is the ratio of the Value added (current US$) of Brazil in 1997 to that in 2001?
Your answer should be very brief. 1.58. What is the ratio of the Value added (current US$) of United Arab Emirates in 1997 to that in 2001?
Make the answer very short. 0.45. What is the ratio of the Value added (current US$) of Bahamas in 1997 to that in 2002?
Offer a terse response. 0.66. What is the ratio of the Value added (current US$) in Belgium in 1997 to that in 2002?
Your answer should be very brief. 1.08. What is the ratio of the Value added (current US$) of Brazil in 1997 to that in 2002?
Provide a short and direct response. 1.82. What is the ratio of the Value added (current US$) in United Arab Emirates in 1997 to that in 2002?
Your answer should be compact. 0.43. What is the ratio of the Value added (current US$) of Bahamas in 1997 to that in 2003?
Provide a short and direct response. 0.69. What is the ratio of the Value added (current US$) in Belgium in 1997 to that in 2003?
Offer a very short reply. 0.92. What is the ratio of the Value added (current US$) of Brazil in 1997 to that in 2003?
Offer a very short reply. 1.41. What is the ratio of the Value added (current US$) in United Arab Emirates in 1997 to that in 2003?
Offer a terse response. 0.41. What is the ratio of the Value added (current US$) in Bahamas in 1998 to that in 1999?
Offer a very short reply. 0.65. What is the ratio of the Value added (current US$) of Belgium in 1998 to that in 1999?
Provide a succinct answer. 1.05. What is the ratio of the Value added (current US$) of Brazil in 1998 to that in 1999?
Ensure brevity in your answer.  1.42. What is the ratio of the Value added (current US$) in United Arab Emirates in 1998 to that in 1999?
Offer a very short reply. 0.9. What is the ratio of the Value added (current US$) of Bahamas in 1998 to that in 2000?
Your answer should be compact. 0.58. What is the ratio of the Value added (current US$) of Belgium in 1998 to that in 2000?
Ensure brevity in your answer.  1.14. What is the ratio of the Value added (current US$) in Brazil in 1998 to that in 2000?
Your response must be concise. 1.22. What is the ratio of the Value added (current US$) in United Arab Emirates in 1998 to that in 2000?
Offer a very short reply. 0.69. What is the ratio of the Value added (current US$) in Bahamas in 1998 to that in 2001?
Your response must be concise. 0.74. What is the ratio of the Value added (current US$) of Belgium in 1998 to that in 2001?
Offer a terse response. 1.17. What is the ratio of the Value added (current US$) in Brazil in 1998 to that in 2001?
Your response must be concise. 1.44. What is the ratio of the Value added (current US$) of United Arab Emirates in 1998 to that in 2001?
Give a very brief answer. 0.47. What is the ratio of the Value added (current US$) of Bahamas in 1998 to that in 2002?
Your answer should be very brief. 0.61. What is the ratio of the Value added (current US$) in Belgium in 1998 to that in 2002?
Offer a very short reply. 1.09. What is the ratio of the Value added (current US$) in Brazil in 1998 to that in 2002?
Offer a very short reply. 1.66. What is the ratio of the Value added (current US$) of United Arab Emirates in 1998 to that in 2002?
Your answer should be very brief. 0.46. What is the ratio of the Value added (current US$) of Bahamas in 1998 to that in 2003?
Your answer should be compact. 0.64. What is the ratio of the Value added (current US$) in Belgium in 1998 to that in 2003?
Offer a very short reply. 0.93. What is the ratio of the Value added (current US$) of Brazil in 1998 to that in 2003?
Keep it short and to the point. 1.29. What is the ratio of the Value added (current US$) in United Arab Emirates in 1998 to that in 2003?
Ensure brevity in your answer.  0.43. What is the ratio of the Value added (current US$) in Bahamas in 1999 to that in 2000?
Keep it short and to the point. 0.9. What is the ratio of the Value added (current US$) in Belgium in 1999 to that in 2000?
Your answer should be compact. 1.09. What is the ratio of the Value added (current US$) in Brazil in 1999 to that in 2000?
Make the answer very short. 0.86. What is the ratio of the Value added (current US$) in United Arab Emirates in 1999 to that in 2000?
Provide a succinct answer. 0.76. What is the ratio of the Value added (current US$) of Bahamas in 1999 to that in 2001?
Give a very brief answer. 1.14. What is the ratio of the Value added (current US$) in Belgium in 1999 to that in 2001?
Provide a short and direct response. 1.12. What is the ratio of the Value added (current US$) in Brazil in 1999 to that in 2001?
Offer a terse response. 1.01. What is the ratio of the Value added (current US$) of United Arab Emirates in 1999 to that in 2001?
Your answer should be compact. 0.53. What is the ratio of the Value added (current US$) in Bahamas in 1999 to that in 2002?
Ensure brevity in your answer.  0.94. What is the ratio of the Value added (current US$) in Belgium in 1999 to that in 2002?
Keep it short and to the point. 1.04. What is the ratio of the Value added (current US$) of Brazil in 1999 to that in 2002?
Keep it short and to the point. 1.17. What is the ratio of the Value added (current US$) of United Arab Emirates in 1999 to that in 2002?
Offer a terse response. 0.5. What is the ratio of the Value added (current US$) in Bahamas in 1999 to that in 2003?
Give a very brief answer. 0.98. What is the ratio of the Value added (current US$) of Belgium in 1999 to that in 2003?
Offer a terse response. 0.88. What is the ratio of the Value added (current US$) of Brazil in 1999 to that in 2003?
Your answer should be compact. 0.9. What is the ratio of the Value added (current US$) in United Arab Emirates in 1999 to that in 2003?
Your response must be concise. 0.47. What is the ratio of the Value added (current US$) of Bahamas in 2000 to that in 2001?
Make the answer very short. 1.27. What is the ratio of the Value added (current US$) in Belgium in 2000 to that in 2001?
Your answer should be compact. 1.03. What is the ratio of the Value added (current US$) of Brazil in 2000 to that in 2001?
Ensure brevity in your answer.  1.18. What is the ratio of the Value added (current US$) in United Arab Emirates in 2000 to that in 2001?
Your answer should be very brief. 0.69. What is the ratio of the Value added (current US$) of Bahamas in 2000 to that in 2002?
Your answer should be very brief. 1.04. What is the ratio of the Value added (current US$) in Belgium in 2000 to that in 2002?
Keep it short and to the point. 0.96. What is the ratio of the Value added (current US$) in Brazil in 2000 to that in 2002?
Keep it short and to the point. 1.36. What is the ratio of the Value added (current US$) of United Arab Emirates in 2000 to that in 2002?
Your answer should be compact. 0.66. What is the ratio of the Value added (current US$) in Bahamas in 2000 to that in 2003?
Your answer should be compact. 1.09. What is the ratio of the Value added (current US$) in Belgium in 2000 to that in 2003?
Make the answer very short. 0.81. What is the ratio of the Value added (current US$) of Brazil in 2000 to that in 2003?
Make the answer very short. 1.06. What is the ratio of the Value added (current US$) in United Arab Emirates in 2000 to that in 2003?
Make the answer very short. 0.62. What is the ratio of the Value added (current US$) in Bahamas in 2001 to that in 2002?
Provide a short and direct response. 0.82. What is the ratio of the Value added (current US$) of Belgium in 2001 to that in 2002?
Your answer should be compact. 0.93. What is the ratio of the Value added (current US$) of Brazil in 2001 to that in 2002?
Ensure brevity in your answer.  1.15. What is the ratio of the Value added (current US$) in United Arab Emirates in 2001 to that in 2002?
Make the answer very short. 0.96. What is the ratio of the Value added (current US$) in Bahamas in 2001 to that in 2003?
Provide a short and direct response. 0.86. What is the ratio of the Value added (current US$) in Belgium in 2001 to that in 2003?
Your answer should be very brief. 0.79. What is the ratio of the Value added (current US$) of Brazil in 2001 to that in 2003?
Offer a very short reply. 0.89. What is the ratio of the Value added (current US$) of United Arab Emirates in 2001 to that in 2003?
Give a very brief answer. 0.9. What is the ratio of the Value added (current US$) in Bahamas in 2002 to that in 2003?
Your response must be concise. 1.05. What is the ratio of the Value added (current US$) in Belgium in 2002 to that in 2003?
Provide a succinct answer. 0.85. What is the ratio of the Value added (current US$) of Brazil in 2002 to that in 2003?
Provide a short and direct response. 0.77. What is the ratio of the Value added (current US$) of United Arab Emirates in 2002 to that in 2003?
Offer a terse response. 0.94. What is the difference between the highest and the second highest Value added (current US$) in Bahamas?
Provide a succinct answer. 1.23e+07. What is the difference between the highest and the second highest Value added (current US$) of Belgium?
Your answer should be compact. 5.35e+07. What is the difference between the highest and the second highest Value added (current US$) of Brazil?
Ensure brevity in your answer.  3.82e+09. What is the difference between the highest and the second highest Value added (current US$) of United Arab Emirates?
Your answer should be very brief. 9.02e+08. What is the difference between the highest and the lowest Value added (current US$) of Bahamas?
Your answer should be very brief. 1.68e+08. What is the difference between the highest and the lowest Value added (current US$) of Belgium?
Offer a terse response. 1.09e+1. What is the difference between the highest and the lowest Value added (current US$) in Brazil?
Ensure brevity in your answer.  5.15e+1. What is the difference between the highest and the lowest Value added (current US$) of United Arab Emirates?
Your answer should be very brief. 1.04e+1. 